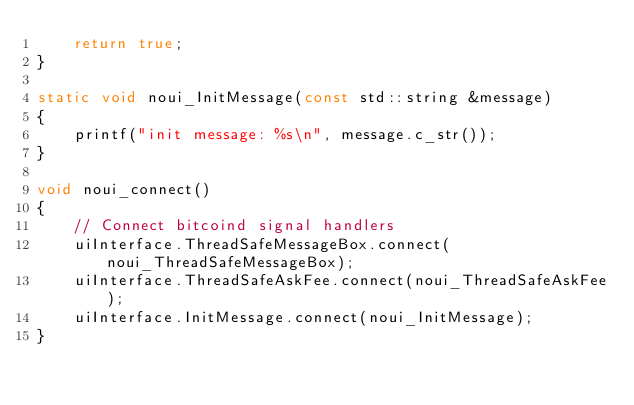<code> <loc_0><loc_0><loc_500><loc_500><_C++_>    return true;
}

static void noui_InitMessage(const std::string &message)
{
    printf("init message: %s\n", message.c_str());
}

void noui_connect()
{
    // Connect bitcoind signal handlers
    uiInterface.ThreadSafeMessageBox.connect(noui_ThreadSafeMessageBox);
    uiInterface.ThreadSafeAskFee.connect(noui_ThreadSafeAskFee);
    uiInterface.InitMessage.connect(noui_InitMessage);
}
</code> 